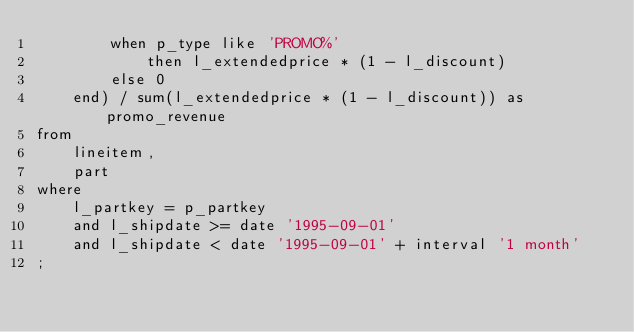Convert code to text. <code><loc_0><loc_0><loc_500><loc_500><_SQL_>		when p_type like 'PROMO%'
			then l_extendedprice * (1 - l_discount)
		else 0
	end) / sum(l_extendedprice * (1 - l_discount)) as promo_revenue
from
	lineitem,
	part
where
	l_partkey = p_partkey
	and l_shipdate >= date '1995-09-01'
	and l_shipdate < date '1995-09-01' + interval '1 month'
;


</code> 